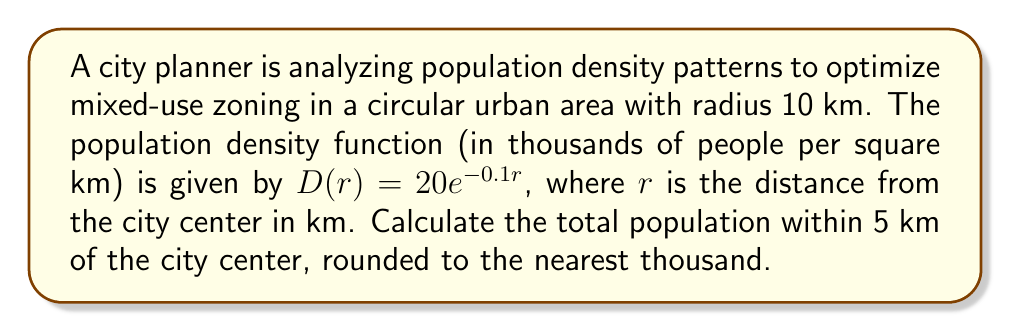Could you help me with this problem? To solve this problem, we need to integrate the population density function over the circular area with radius 5 km. Here's the step-by-step solution:

1) The total population is given by the double integral of the density function over the circular region:

   $$P = \int_{0}^{2\pi}\int_{0}^{5} D(r) \cdot r \, dr \, d\theta$$

2) Since the density function is radially symmetric, we can simplify this to:

   $$P = 2\pi \int_{0}^{5} D(r) \cdot r \, dr$$

3) Substituting the given density function:

   $$P = 2\pi \int_{0}^{5} 20e^{-0.1r} \cdot r \, dr$$

4) Let $u = -0.1r$, then $du = -0.1 \, dr$ and $dr = -10 \, du$:

   $$P = 2\pi \cdot 20 \cdot (-100) \int_{0}^{-0.5} e^u \cdot u \, du$$

5) Integrate by parts with $dv = u \, du$ and $v = u$:

   $$P = -4000\pi \left[ ue^u - \int e^u \, du \right]_{0}^{-0.5}$$

6) Evaluating the integral:

   $$P = -4000\pi \left[ (-0.5e^{-0.5} + e^{-0.5}) - (0 + 1) \right]$$

7) Simplifying:

   $$P = -4000\pi \left[ e^{-0.5} - 0.5e^{-0.5} - 1 \right]$$

8) Calculating the value (using a calculator):

   $$P \approx 1,013,211$$

9) Rounding to the nearest thousand:

   $$P \approx 1,013,000$$
Answer: 1,013,000 